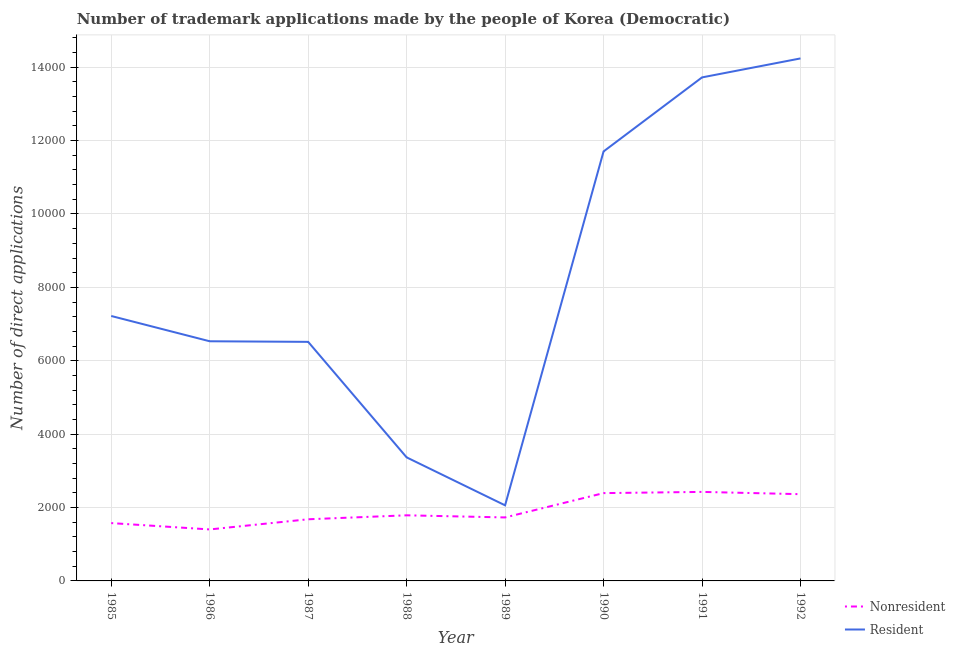How many different coloured lines are there?
Your response must be concise. 2. Does the line corresponding to number of trademark applications made by residents intersect with the line corresponding to number of trademark applications made by non residents?
Offer a terse response. No. Is the number of lines equal to the number of legend labels?
Keep it short and to the point. Yes. What is the number of trademark applications made by residents in 1989?
Provide a short and direct response. 2060. Across all years, what is the maximum number of trademark applications made by residents?
Offer a very short reply. 1.42e+04. Across all years, what is the minimum number of trademark applications made by residents?
Your answer should be very brief. 2060. In which year was the number of trademark applications made by residents minimum?
Ensure brevity in your answer.  1989. What is the total number of trademark applications made by non residents in the graph?
Offer a terse response. 1.54e+04. What is the difference between the number of trademark applications made by non residents in 1986 and that in 1988?
Keep it short and to the point. -385. What is the difference between the number of trademark applications made by non residents in 1989 and the number of trademark applications made by residents in 1990?
Offer a very short reply. -9974. What is the average number of trademark applications made by residents per year?
Provide a short and direct response. 8169.75. In the year 1989, what is the difference between the number of trademark applications made by residents and number of trademark applications made by non residents?
Ensure brevity in your answer.  330. In how many years, is the number of trademark applications made by residents greater than 2000?
Give a very brief answer. 8. What is the ratio of the number of trademark applications made by non residents in 1987 to that in 1990?
Provide a short and direct response. 0.7. Is the number of trademark applications made by non residents in 1985 less than that in 1991?
Keep it short and to the point. Yes. What is the difference between the highest and the second highest number of trademark applications made by residents?
Make the answer very short. 517. What is the difference between the highest and the lowest number of trademark applications made by non residents?
Make the answer very short. 1023. Does the number of trademark applications made by non residents monotonically increase over the years?
Keep it short and to the point. No. Is the number of trademark applications made by residents strictly less than the number of trademark applications made by non residents over the years?
Keep it short and to the point. No. How many lines are there?
Ensure brevity in your answer.  2. What is the difference between two consecutive major ticks on the Y-axis?
Provide a short and direct response. 2000. Does the graph contain grids?
Your answer should be very brief. Yes. How many legend labels are there?
Your answer should be very brief. 2. How are the legend labels stacked?
Your response must be concise. Vertical. What is the title of the graph?
Keep it short and to the point. Number of trademark applications made by the people of Korea (Democratic). What is the label or title of the X-axis?
Provide a succinct answer. Year. What is the label or title of the Y-axis?
Make the answer very short. Number of direct applications. What is the Number of direct applications in Nonresident in 1985?
Ensure brevity in your answer.  1576. What is the Number of direct applications of Resident in 1985?
Offer a terse response. 7220. What is the Number of direct applications in Nonresident in 1986?
Offer a very short reply. 1403. What is the Number of direct applications of Resident in 1986?
Give a very brief answer. 6531. What is the Number of direct applications of Nonresident in 1987?
Provide a short and direct response. 1680. What is the Number of direct applications of Resident in 1987?
Make the answer very short. 6515. What is the Number of direct applications of Nonresident in 1988?
Your answer should be very brief. 1788. What is the Number of direct applications in Resident in 1988?
Ensure brevity in your answer.  3367. What is the Number of direct applications in Nonresident in 1989?
Your answer should be compact. 1730. What is the Number of direct applications in Resident in 1989?
Ensure brevity in your answer.  2060. What is the Number of direct applications of Nonresident in 1990?
Offer a very short reply. 2393. What is the Number of direct applications of Resident in 1990?
Ensure brevity in your answer.  1.17e+04. What is the Number of direct applications in Nonresident in 1991?
Provide a succinct answer. 2426. What is the Number of direct applications in Resident in 1991?
Keep it short and to the point. 1.37e+04. What is the Number of direct applications of Nonresident in 1992?
Your response must be concise. 2364. What is the Number of direct applications in Resident in 1992?
Your answer should be very brief. 1.42e+04. Across all years, what is the maximum Number of direct applications in Nonresident?
Your response must be concise. 2426. Across all years, what is the maximum Number of direct applications in Resident?
Provide a succinct answer. 1.42e+04. Across all years, what is the minimum Number of direct applications in Nonresident?
Make the answer very short. 1403. Across all years, what is the minimum Number of direct applications in Resident?
Ensure brevity in your answer.  2060. What is the total Number of direct applications of Nonresident in the graph?
Your response must be concise. 1.54e+04. What is the total Number of direct applications of Resident in the graph?
Your answer should be very brief. 6.54e+04. What is the difference between the Number of direct applications of Nonresident in 1985 and that in 1986?
Offer a very short reply. 173. What is the difference between the Number of direct applications of Resident in 1985 and that in 1986?
Give a very brief answer. 689. What is the difference between the Number of direct applications of Nonresident in 1985 and that in 1987?
Give a very brief answer. -104. What is the difference between the Number of direct applications in Resident in 1985 and that in 1987?
Your response must be concise. 705. What is the difference between the Number of direct applications of Nonresident in 1985 and that in 1988?
Your answer should be compact. -212. What is the difference between the Number of direct applications in Resident in 1985 and that in 1988?
Provide a short and direct response. 3853. What is the difference between the Number of direct applications of Nonresident in 1985 and that in 1989?
Offer a very short reply. -154. What is the difference between the Number of direct applications of Resident in 1985 and that in 1989?
Keep it short and to the point. 5160. What is the difference between the Number of direct applications of Nonresident in 1985 and that in 1990?
Your answer should be very brief. -817. What is the difference between the Number of direct applications in Resident in 1985 and that in 1990?
Provide a succinct answer. -4484. What is the difference between the Number of direct applications of Nonresident in 1985 and that in 1991?
Provide a short and direct response. -850. What is the difference between the Number of direct applications of Resident in 1985 and that in 1991?
Give a very brief answer. -6502. What is the difference between the Number of direct applications of Nonresident in 1985 and that in 1992?
Ensure brevity in your answer.  -788. What is the difference between the Number of direct applications in Resident in 1985 and that in 1992?
Your response must be concise. -7019. What is the difference between the Number of direct applications in Nonresident in 1986 and that in 1987?
Your answer should be very brief. -277. What is the difference between the Number of direct applications in Resident in 1986 and that in 1987?
Offer a terse response. 16. What is the difference between the Number of direct applications in Nonresident in 1986 and that in 1988?
Give a very brief answer. -385. What is the difference between the Number of direct applications of Resident in 1986 and that in 1988?
Provide a short and direct response. 3164. What is the difference between the Number of direct applications in Nonresident in 1986 and that in 1989?
Provide a succinct answer. -327. What is the difference between the Number of direct applications in Resident in 1986 and that in 1989?
Provide a succinct answer. 4471. What is the difference between the Number of direct applications of Nonresident in 1986 and that in 1990?
Offer a very short reply. -990. What is the difference between the Number of direct applications of Resident in 1986 and that in 1990?
Offer a very short reply. -5173. What is the difference between the Number of direct applications in Nonresident in 1986 and that in 1991?
Keep it short and to the point. -1023. What is the difference between the Number of direct applications of Resident in 1986 and that in 1991?
Provide a succinct answer. -7191. What is the difference between the Number of direct applications of Nonresident in 1986 and that in 1992?
Provide a succinct answer. -961. What is the difference between the Number of direct applications in Resident in 1986 and that in 1992?
Your response must be concise. -7708. What is the difference between the Number of direct applications of Nonresident in 1987 and that in 1988?
Your answer should be very brief. -108. What is the difference between the Number of direct applications of Resident in 1987 and that in 1988?
Keep it short and to the point. 3148. What is the difference between the Number of direct applications of Resident in 1987 and that in 1989?
Offer a very short reply. 4455. What is the difference between the Number of direct applications in Nonresident in 1987 and that in 1990?
Keep it short and to the point. -713. What is the difference between the Number of direct applications of Resident in 1987 and that in 1990?
Provide a succinct answer. -5189. What is the difference between the Number of direct applications of Nonresident in 1987 and that in 1991?
Ensure brevity in your answer.  -746. What is the difference between the Number of direct applications of Resident in 1987 and that in 1991?
Your answer should be compact. -7207. What is the difference between the Number of direct applications of Nonresident in 1987 and that in 1992?
Ensure brevity in your answer.  -684. What is the difference between the Number of direct applications in Resident in 1987 and that in 1992?
Keep it short and to the point. -7724. What is the difference between the Number of direct applications in Resident in 1988 and that in 1989?
Offer a very short reply. 1307. What is the difference between the Number of direct applications of Nonresident in 1988 and that in 1990?
Your response must be concise. -605. What is the difference between the Number of direct applications in Resident in 1988 and that in 1990?
Your answer should be very brief. -8337. What is the difference between the Number of direct applications in Nonresident in 1988 and that in 1991?
Offer a very short reply. -638. What is the difference between the Number of direct applications in Resident in 1988 and that in 1991?
Keep it short and to the point. -1.04e+04. What is the difference between the Number of direct applications of Nonresident in 1988 and that in 1992?
Give a very brief answer. -576. What is the difference between the Number of direct applications of Resident in 1988 and that in 1992?
Your answer should be compact. -1.09e+04. What is the difference between the Number of direct applications of Nonresident in 1989 and that in 1990?
Give a very brief answer. -663. What is the difference between the Number of direct applications in Resident in 1989 and that in 1990?
Give a very brief answer. -9644. What is the difference between the Number of direct applications of Nonresident in 1989 and that in 1991?
Offer a terse response. -696. What is the difference between the Number of direct applications in Resident in 1989 and that in 1991?
Make the answer very short. -1.17e+04. What is the difference between the Number of direct applications of Nonresident in 1989 and that in 1992?
Offer a terse response. -634. What is the difference between the Number of direct applications of Resident in 1989 and that in 1992?
Ensure brevity in your answer.  -1.22e+04. What is the difference between the Number of direct applications in Nonresident in 1990 and that in 1991?
Give a very brief answer. -33. What is the difference between the Number of direct applications in Resident in 1990 and that in 1991?
Your response must be concise. -2018. What is the difference between the Number of direct applications in Resident in 1990 and that in 1992?
Your answer should be very brief. -2535. What is the difference between the Number of direct applications of Resident in 1991 and that in 1992?
Ensure brevity in your answer.  -517. What is the difference between the Number of direct applications of Nonresident in 1985 and the Number of direct applications of Resident in 1986?
Make the answer very short. -4955. What is the difference between the Number of direct applications of Nonresident in 1985 and the Number of direct applications of Resident in 1987?
Offer a terse response. -4939. What is the difference between the Number of direct applications in Nonresident in 1985 and the Number of direct applications in Resident in 1988?
Provide a short and direct response. -1791. What is the difference between the Number of direct applications in Nonresident in 1985 and the Number of direct applications in Resident in 1989?
Provide a succinct answer. -484. What is the difference between the Number of direct applications in Nonresident in 1985 and the Number of direct applications in Resident in 1990?
Provide a short and direct response. -1.01e+04. What is the difference between the Number of direct applications in Nonresident in 1985 and the Number of direct applications in Resident in 1991?
Your response must be concise. -1.21e+04. What is the difference between the Number of direct applications of Nonresident in 1985 and the Number of direct applications of Resident in 1992?
Provide a succinct answer. -1.27e+04. What is the difference between the Number of direct applications in Nonresident in 1986 and the Number of direct applications in Resident in 1987?
Your response must be concise. -5112. What is the difference between the Number of direct applications of Nonresident in 1986 and the Number of direct applications of Resident in 1988?
Your answer should be very brief. -1964. What is the difference between the Number of direct applications of Nonresident in 1986 and the Number of direct applications of Resident in 1989?
Ensure brevity in your answer.  -657. What is the difference between the Number of direct applications in Nonresident in 1986 and the Number of direct applications in Resident in 1990?
Make the answer very short. -1.03e+04. What is the difference between the Number of direct applications in Nonresident in 1986 and the Number of direct applications in Resident in 1991?
Make the answer very short. -1.23e+04. What is the difference between the Number of direct applications of Nonresident in 1986 and the Number of direct applications of Resident in 1992?
Ensure brevity in your answer.  -1.28e+04. What is the difference between the Number of direct applications in Nonresident in 1987 and the Number of direct applications in Resident in 1988?
Your answer should be very brief. -1687. What is the difference between the Number of direct applications in Nonresident in 1987 and the Number of direct applications in Resident in 1989?
Provide a short and direct response. -380. What is the difference between the Number of direct applications of Nonresident in 1987 and the Number of direct applications of Resident in 1990?
Give a very brief answer. -1.00e+04. What is the difference between the Number of direct applications in Nonresident in 1987 and the Number of direct applications in Resident in 1991?
Offer a terse response. -1.20e+04. What is the difference between the Number of direct applications of Nonresident in 1987 and the Number of direct applications of Resident in 1992?
Give a very brief answer. -1.26e+04. What is the difference between the Number of direct applications of Nonresident in 1988 and the Number of direct applications of Resident in 1989?
Provide a short and direct response. -272. What is the difference between the Number of direct applications in Nonresident in 1988 and the Number of direct applications in Resident in 1990?
Your answer should be very brief. -9916. What is the difference between the Number of direct applications in Nonresident in 1988 and the Number of direct applications in Resident in 1991?
Give a very brief answer. -1.19e+04. What is the difference between the Number of direct applications in Nonresident in 1988 and the Number of direct applications in Resident in 1992?
Keep it short and to the point. -1.25e+04. What is the difference between the Number of direct applications in Nonresident in 1989 and the Number of direct applications in Resident in 1990?
Provide a short and direct response. -9974. What is the difference between the Number of direct applications of Nonresident in 1989 and the Number of direct applications of Resident in 1991?
Your response must be concise. -1.20e+04. What is the difference between the Number of direct applications of Nonresident in 1989 and the Number of direct applications of Resident in 1992?
Make the answer very short. -1.25e+04. What is the difference between the Number of direct applications of Nonresident in 1990 and the Number of direct applications of Resident in 1991?
Your answer should be very brief. -1.13e+04. What is the difference between the Number of direct applications in Nonresident in 1990 and the Number of direct applications in Resident in 1992?
Give a very brief answer. -1.18e+04. What is the difference between the Number of direct applications of Nonresident in 1991 and the Number of direct applications of Resident in 1992?
Your answer should be compact. -1.18e+04. What is the average Number of direct applications in Nonresident per year?
Your response must be concise. 1920. What is the average Number of direct applications in Resident per year?
Your response must be concise. 8169.75. In the year 1985, what is the difference between the Number of direct applications of Nonresident and Number of direct applications of Resident?
Your answer should be compact. -5644. In the year 1986, what is the difference between the Number of direct applications of Nonresident and Number of direct applications of Resident?
Provide a succinct answer. -5128. In the year 1987, what is the difference between the Number of direct applications of Nonresident and Number of direct applications of Resident?
Ensure brevity in your answer.  -4835. In the year 1988, what is the difference between the Number of direct applications in Nonresident and Number of direct applications in Resident?
Provide a short and direct response. -1579. In the year 1989, what is the difference between the Number of direct applications of Nonresident and Number of direct applications of Resident?
Your response must be concise. -330. In the year 1990, what is the difference between the Number of direct applications of Nonresident and Number of direct applications of Resident?
Provide a short and direct response. -9311. In the year 1991, what is the difference between the Number of direct applications in Nonresident and Number of direct applications in Resident?
Provide a succinct answer. -1.13e+04. In the year 1992, what is the difference between the Number of direct applications of Nonresident and Number of direct applications of Resident?
Your answer should be compact. -1.19e+04. What is the ratio of the Number of direct applications in Nonresident in 1985 to that in 1986?
Provide a succinct answer. 1.12. What is the ratio of the Number of direct applications of Resident in 1985 to that in 1986?
Your answer should be compact. 1.11. What is the ratio of the Number of direct applications of Nonresident in 1985 to that in 1987?
Give a very brief answer. 0.94. What is the ratio of the Number of direct applications of Resident in 1985 to that in 1987?
Provide a short and direct response. 1.11. What is the ratio of the Number of direct applications of Nonresident in 1985 to that in 1988?
Give a very brief answer. 0.88. What is the ratio of the Number of direct applications in Resident in 1985 to that in 1988?
Provide a succinct answer. 2.14. What is the ratio of the Number of direct applications in Nonresident in 1985 to that in 1989?
Your answer should be very brief. 0.91. What is the ratio of the Number of direct applications in Resident in 1985 to that in 1989?
Provide a short and direct response. 3.5. What is the ratio of the Number of direct applications of Nonresident in 1985 to that in 1990?
Ensure brevity in your answer.  0.66. What is the ratio of the Number of direct applications of Resident in 1985 to that in 1990?
Make the answer very short. 0.62. What is the ratio of the Number of direct applications in Nonresident in 1985 to that in 1991?
Your answer should be compact. 0.65. What is the ratio of the Number of direct applications of Resident in 1985 to that in 1991?
Keep it short and to the point. 0.53. What is the ratio of the Number of direct applications of Resident in 1985 to that in 1992?
Offer a terse response. 0.51. What is the ratio of the Number of direct applications in Nonresident in 1986 to that in 1987?
Provide a short and direct response. 0.84. What is the ratio of the Number of direct applications of Nonresident in 1986 to that in 1988?
Ensure brevity in your answer.  0.78. What is the ratio of the Number of direct applications in Resident in 1986 to that in 1988?
Offer a terse response. 1.94. What is the ratio of the Number of direct applications in Nonresident in 1986 to that in 1989?
Your answer should be very brief. 0.81. What is the ratio of the Number of direct applications of Resident in 1986 to that in 1989?
Provide a short and direct response. 3.17. What is the ratio of the Number of direct applications of Nonresident in 1986 to that in 1990?
Ensure brevity in your answer.  0.59. What is the ratio of the Number of direct applications of Resident in 1986 to that in 1990?
Give a very brief answer. 0.56. What is the ratio of the Number of direct applications in Nonresident in 1986 to that in 1991?
Offer a very short reply. 0.58. What is the ratio of the Number of direct applications in Resident in 1986 to that in 1991?
Provide a succinct answer. 0.48. What is the ratio of the Number of direct applications in Nonresident in 1986 to that in 1992?
Make the answer very short. 0.59. What is the ratio of the Number of direct applications of Resident in 1986 to that in 1992?
Ensure brevity in your answer.  0.46. What is the ratio of the Number of direct applications of Nonresident in 1987 to that in 1988?
Provide a short and direct response. 0.94. What is the ratio of the Number of direct applications of Resident in 1987 to that in 1988?
Your response must be concise. 1.94. What is the ratio of the Number of direct applications of Nonresident in 1987 to that in 1989?
Your answer should be very brief. 0.97. What is the ratio of the Number of direct applications in Resident in 1987 to that in 1989?
Give a very brief answer. 3.16. What is the ratio of the Number of direct applications of Nonresident in 1987 to that in 1990?
Ensure brevity in your answer.  0.7. What is the ratio of the Number of direct applications in Resident in 1987 to that in 1990?
Make the answer very short. 0.56. What is the ratio of the Number of direct applications of Nonresident in 1987 to that in 1991?
Your answer should be very brief. 0.69. What is the ratio of the Number of direct applications of Resident in 1987 to that in 1991?
Give a very brief answer. 0.47. What is the ratio of the Number of direct applications in Nonresident in 1987 to that in 1992?
Provide a short and direct response. 0.71. What is the ratio of the Number of direct applications in Resident in 1987 to that in 1992?
Provide a short and direct response. 0.46. What is the ratio of the Number of direct applications of Nonresident in 1988 to that in 1989?
Provide a succinct answer. 1.03. What is the ratio of the Number of direct applications of Resident in 1988 to that in 1989?
Your response must be concise. 1.63. What is the ratio of the Number of direct applications of Nonresident in 1988 to that in 1990?
Make the answer very short. 0.75. What is the ratio of the Number of direct applications in Resident in 1988 to that in 1990?
Give a very brief answer. 0.29. What is the ratio of the Number of direct applications of Nonresident in 1988 to that in 1991?
Offer a terse response. 0.74. What is the ratio of the Number of direct applications in Resident in 1988 to that in 1991?
Give a very brief answer. 0.25. What is the ratio of the Number of direct applications in Nonresident in 1988 to that in 1992?
Provide a succinct answer. 0.76. What is the ratio of the Number of direct applications of Resident in 1988 to that in 1992?
Your response must be concise. 0.24. What is the ratio of the Number of direct applications of Nonresident in 1989 to that in 1990?
Your answer should be compact. 0.72. What is the ratio of the Number of direct applications in Resident in 1989 to that in 1990?
Provide a succinct answer. 0.18. What is the ratio of the Number of direct applications in Nonresident in 1989 to that in 1991?
Offer a very short reply. 0.71. What is the ratio of the Number of direct applications of Resident in 1989 to that in 1991?
Provide a short and direct response. 0.15. What is the ratio of the Number of direct applications of Nonresident in 1989 to that in 1992?
Offer a very short reply. 0.73. What is the ratio of the Number of direct applications of Resident in 1989 to that in 1992?
Offer a terse response. 0.14. What is the ratio of the Number of direct applications of Nonresident in 1990 to that in 1991?
Keep it short and to the point. 0.99. What is the ratio of the Number of direct applications of Resident in 1990 to that in 1991?
Your answer should be compact. 0.85. What is the ratio of the Number of direct applications of Nonresident in 1990 to that in 1992?
Offer a terse response. 1.01. What is the ratio of the Number of direct applications of Resident in 1990 to that in 1992?
Your answer should be very brief. 0.82. What is the ratio of the Number of direct applications in Nonresident in 1991 to that in 1992?
Make the answer very short. 1.03. What is the ratio of the Number of direct applications of Resident in 1991 to that in 1992?
Offer a terse response. 0.96. What is the difference between the highest and the second highest Number of direct applications of Resident?
Give a very brief answer. 517. What is the difference between the highest and the lowest Number of direct applications in Nonresident?
Provide a succinct answer. 1023. What is the difference between the highest and the lowest Number of direct applications of Resident?
Ensure brevity in your answer.  1.22e+04. 